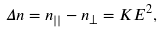Convert formula to latex. <formula><loc_0><loc_0><loc_500><loc_500>\Delta n = n _ { | | } - n _ { \perp } = K E ^ { 2 } ,</formula> 